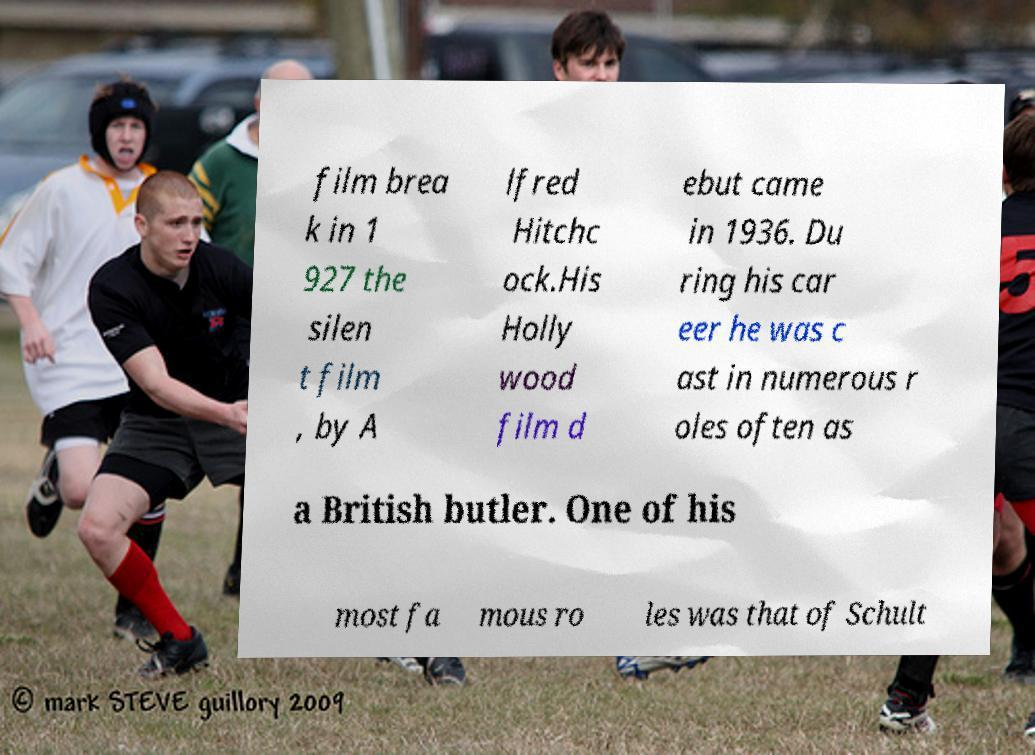Could you assist in decoding the text presented in this image and type it out clearly? film brea k in 1 927 the silen t film , by A lfred Hitchc ock.His Holly wood film d ebut came in 1936. Du ring his car eer he was c ast in numerous r oles often as a British butler. One of his most fa mous ro les was that of Schult 